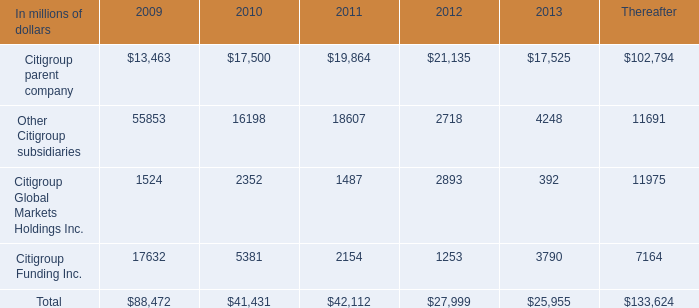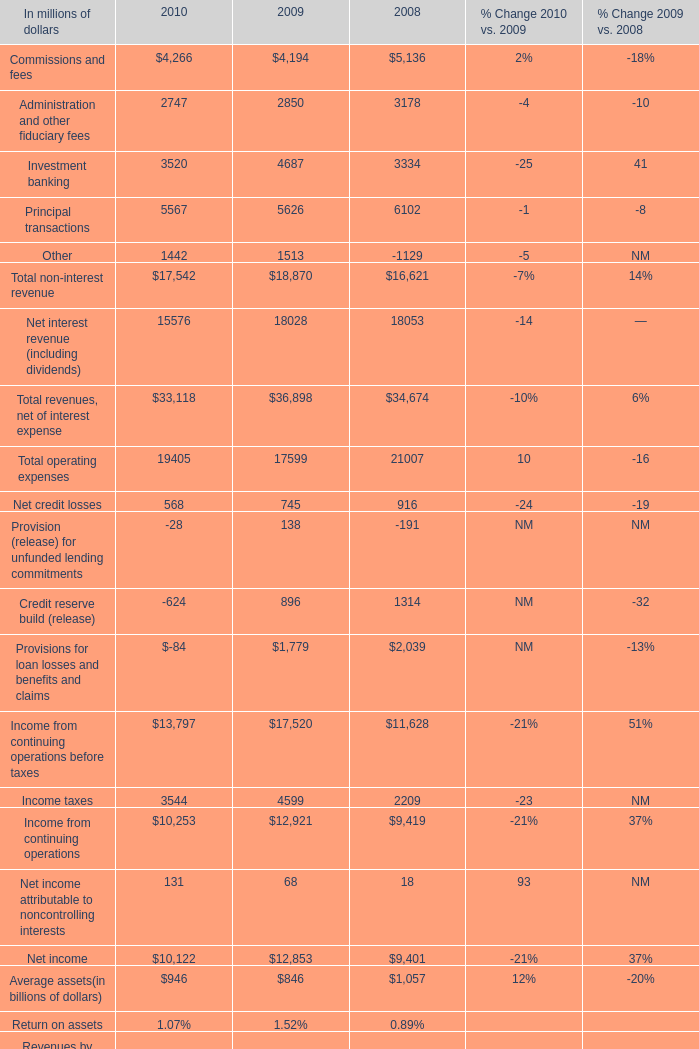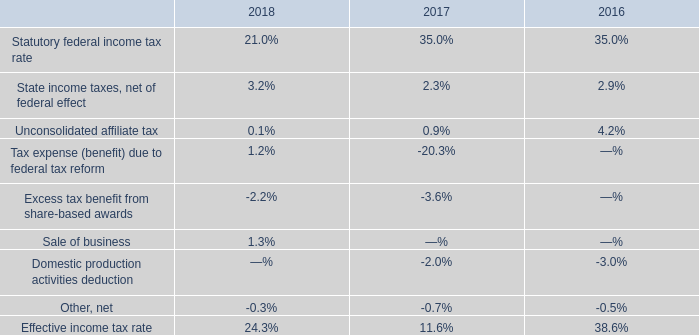What is the average amount of Other Citigroup subsidiaries of 2013, and Principal transactions of 2010 ? 
Computations: ((4248.0 + 5567.0) / 2)
Answer: 4907.5. 